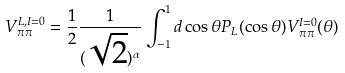Convert formula to latex. <formula><loc_0><loc_0><loc_500><loc_500>V _ { \pi \pi } ^ { L , I = 0 } = \frac { 1 } { 2 } \frac { 1 } { ( \sqrt { 2 } ) ^ { \alpha } } \int _ { - 1 } ^ { 1 } d \cos \theta { P } _ { L } ( \cos \theta ) V _ { \pi \pi } ^ { I = 0 } ( \theta )</formula> 